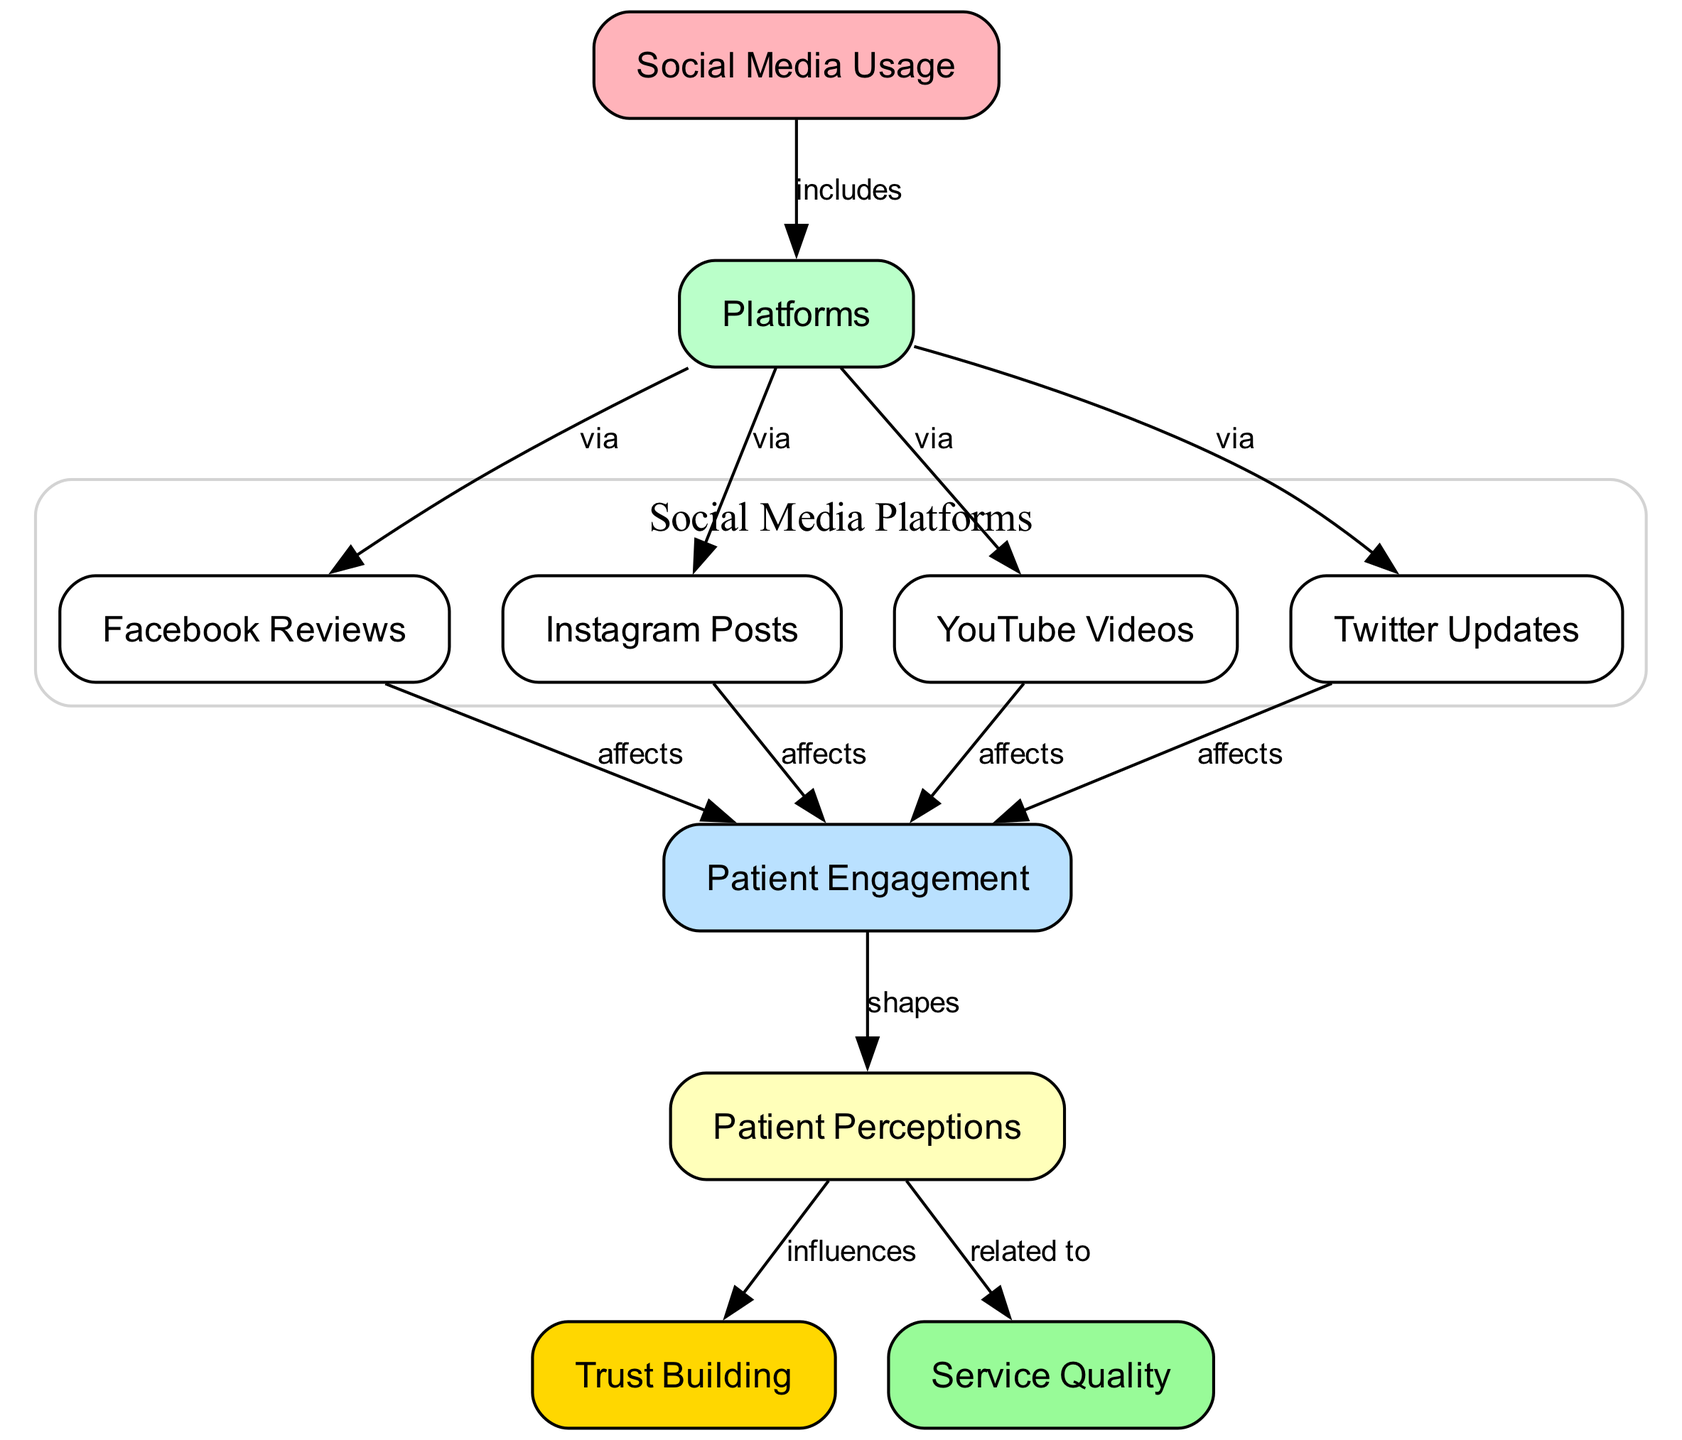What is the total number of nodes in the diagram? The diagram contains multiple nodes representing various aspects related to social media and patient perceptions. By counting each unique node listed, we find there are 10 nodes in total.
Answer: 10 Which node represents 'Facebook Reviews'? In the diagram, each node has a specific label. The node labeled 'Facebook Reviews' directly corresponds to the name found in the list of nodes.
Answer: Facebook Reviews How many platforms are listed in the diagram? The diagram identifies four platforms used for social media, which are explicitly labeled as nodes: Facebook Reviews, Instagram Posts, YouTube Videos, and Twitter Updates. By counting these, we find a total of four platforms.
Answer: 4 Which node influences 'Trust Building'? The diagram has a directional edge from 'Perceptions' to 'Trust Building.' This indicates that 'Perceptions' is the node that has a direct influence over 'Trust Building' in the context of social media's impact on dental services.
Answer: Perceptions What is the relationship between 'Patient Engagement' and 'Perceptions'? In the diagram, there is a directed edge from 'Patient Engagement' to 'Perceptions,' which signifies that 'Patient Engagement' shapes 'Perceptions.' This defines a causal or influential relationship between the two nodes.
Answer: shapes How do 'Instagram Posts' affect 'Patient Engagement'? The diagram shows that there is a direct connection from 'Instagram Posts' to 'Patient Engagement,' indicating that 'Instagram Posts' have a specific effect on patient engagement levels.
Answer: affects 